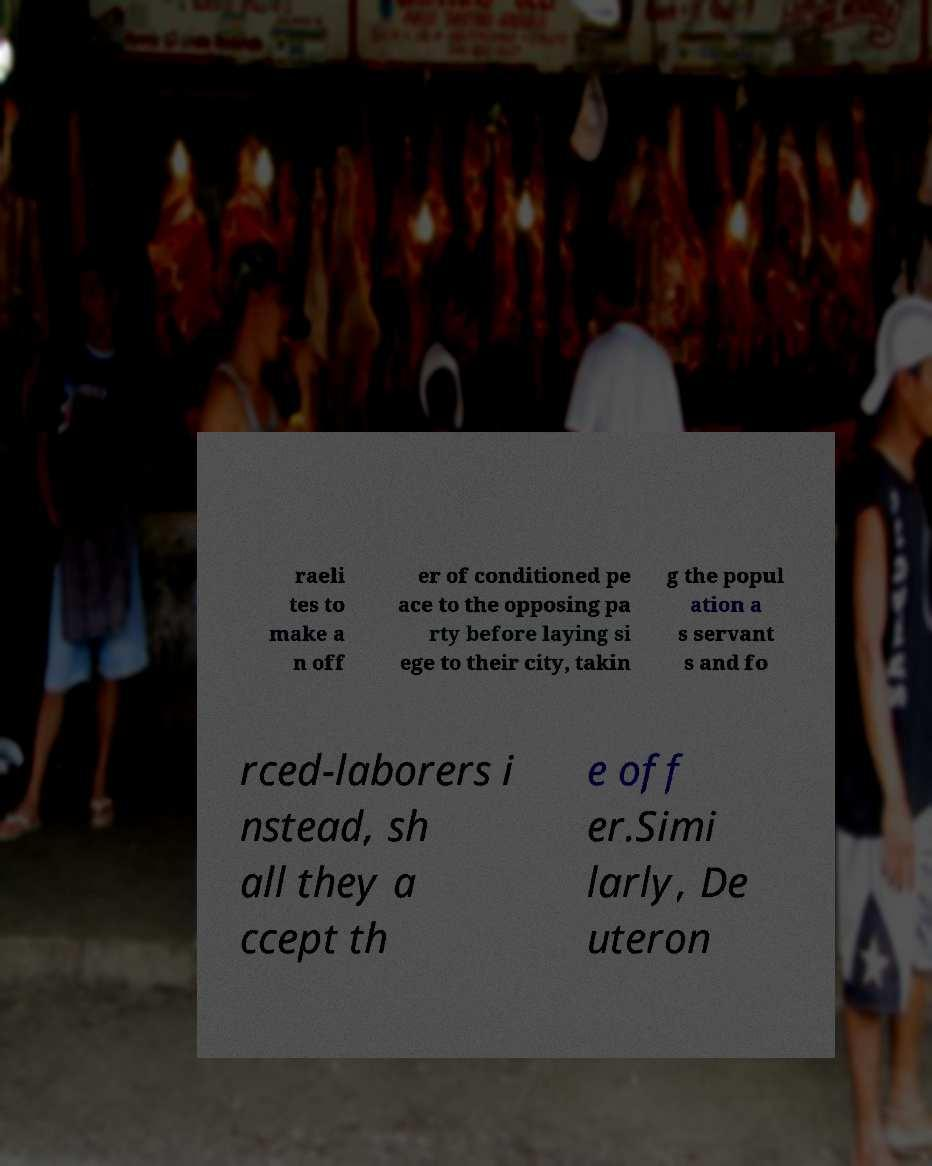Can you read and provide the text displayed in the image?This photo seems to have some interesting text. Can you extract and type it out for me? raeli tes to make a n off er of conditioned pe ace to the opposing pa rty before laying si ege to their city, takin g the popul ation a s servant s and fo rced-laborers i nstead, sh all they a ccept th e off er.Simi larly, De uteron 